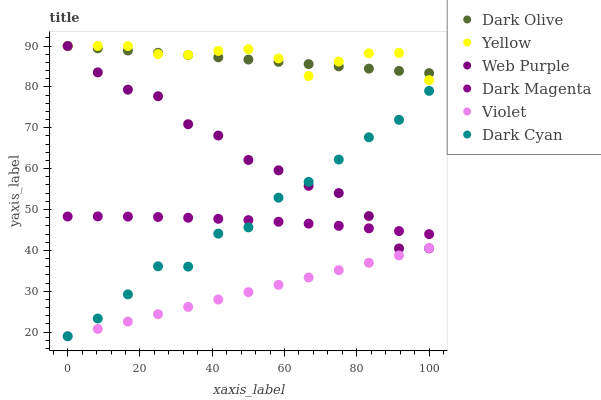Does Violet have the minimum area under the curve?
Answer yes or no. Yes. Does Yellow have the maximum area under the curve?
Answer yes or no. Yes. Does Dark Olive have the minimum area under the curve?
Answer yes or no. No. Does Dark Olive have the maximum area under the curve?
Answer yes or no. No. Is Violet the smoothest?
Answer yes or no. Yes. Is Dark Cyan the roughest?
Answer yes or no. Yes. Is Dark Olive the smoothest?
Answer yes or no. No. Is Dark Olive the roughest?
Answer yes or no. No. Does Violet have the lowest value?
Answer yes or no. Yes. Does Yellow have the lowest value?
Answer yes or no. No. Does Web Purple have the highest value?
Answer yes or no. Yes. Does Violet have the highest value?
Answer yes or no. No. Is Violet less than Yellow?
Answer yes or no. Yes. Is Dark Olive greater than Dark Magenta?
Answer yes or no. Yes. Does Web Purple intersect Dark Olive?
Answer yes or no. Yes. Is Web Purple less than Dark Olive?
Answer yes or no. No. Is Web Purple greater than Dark Olive?
Answer yes or no. No. Does Violet intersect Yellow?
Answer yes or no. No. 